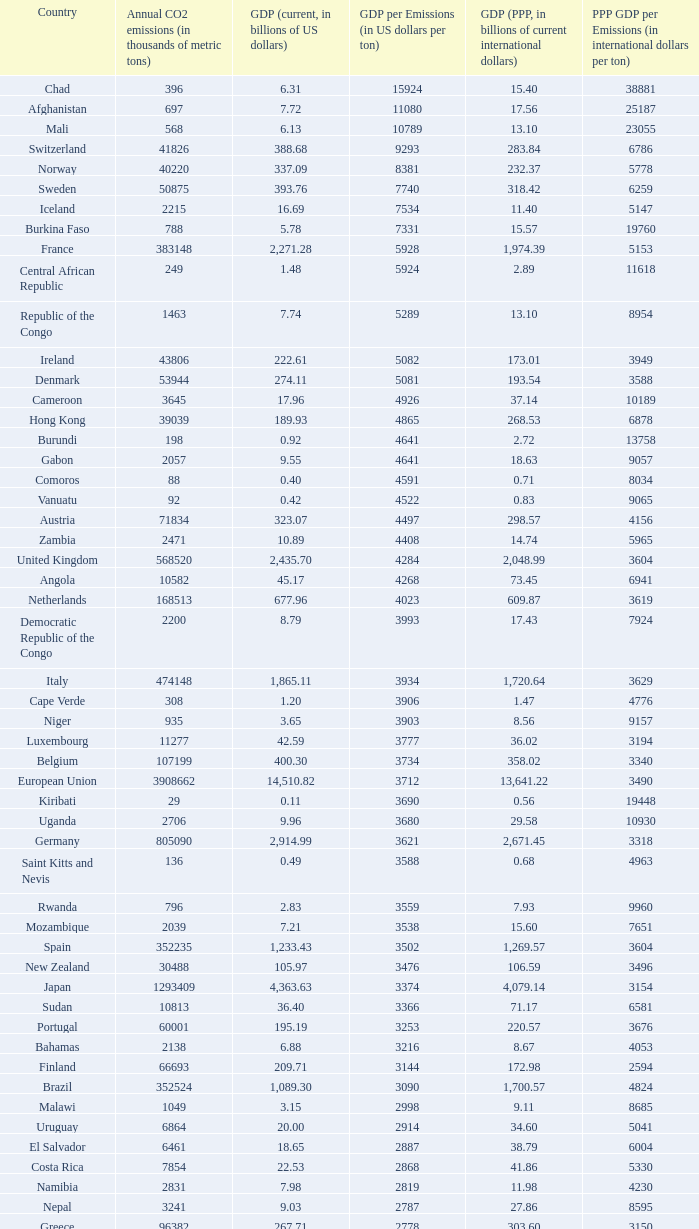When the gdp (ppp, in billions of current international dollars) is 7.93, what is the maximum ppp gdp per emissions (in international dollars per ton)? 9960.0. 